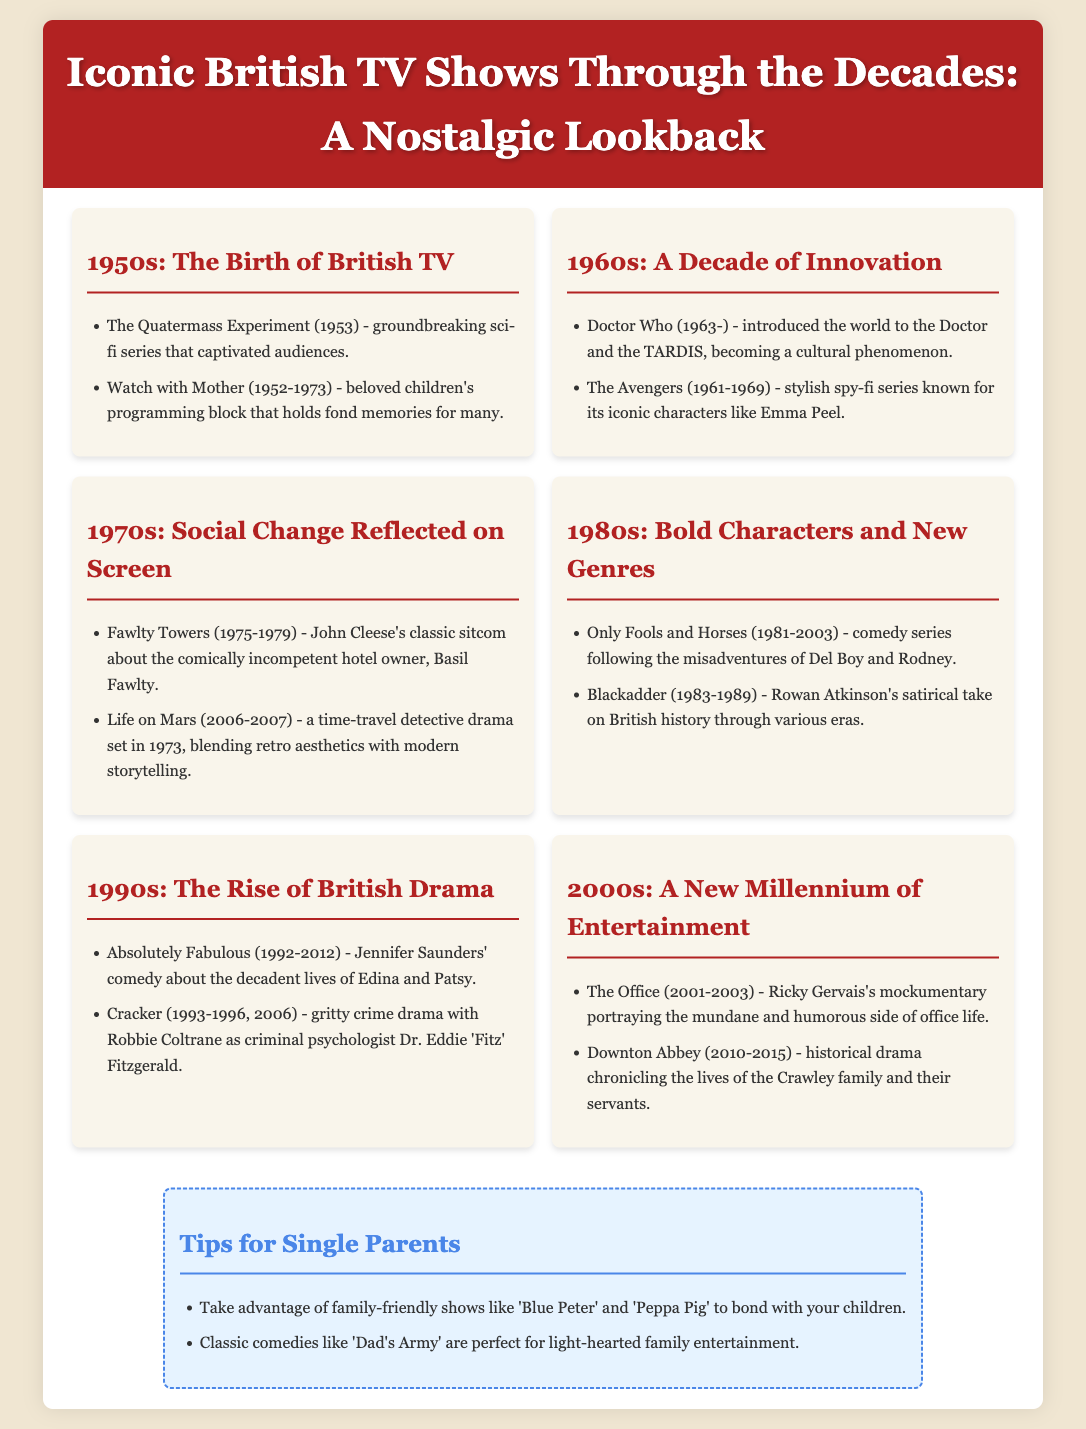What was the first sci-fi series mentioned? The first sci-fi series listed in the 1950s section is "The Quatermass Experiment".
Answer: The Quatermass Experiment Which stylish spy-fi series featured Emma Peel? In the 1960s section, "The Avengers" is noted for its iconic character Emma Peel.
Answer: The Avengers What humorous show follows the misadventures of Del Boy? "Only Fools and Horses" is noted as the comedy series featuring Del Boy and Rodney in the 1980s section.
Answer: Only Fools and Horses Which classic sitcom starred John Cleese? The 1970s section features "Fawlty Towers," a classic sitcom starring John Cleese.
Answer: Fawlty Towers How many years did "Doctor Who" initially run before this document's cut-off date? "Doctor Who" began in 1963 and continues, making it over 60 years old as of October 2023.
Answer: 60+ What decade introduced "Absolutely Fabulous"? The 1990s section mentions "Absolutely Fabulous," making it a product of the 1990s.
Answer: 1990s What genre is most represented in the 2000s section? The 2000s section features a mix of comedies and dramas, but "The Office" leans toward comedy.
Answer: Comedy Which show blends retro aesthetics with modern storytelling? "Life on Mars" in the 1970s section blends retro aesthetics with modern storytelling.
Answer: Life on Mars What tips are offered for single parents in the document? The tips section suggests family-friendly shows like "Blue Peter" and classic comedies like "Dad's Army" for bonding.
Answer: Blue Peter, Dad's Army 